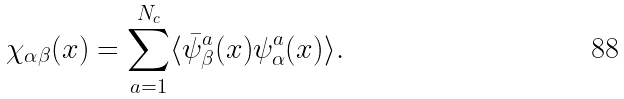<formula> <loc_0><loc_0><loc_500><loc_500>\chi _ { \alpha \beta } ( x ) = \sum _ { a = 1 } ^ { N _ { c } } \langle \bar { \psi } ^ { a } _ { \beta } ( x ) \psi ^ { a } _ { \alpha } ( x ) \rangle .</formula> 